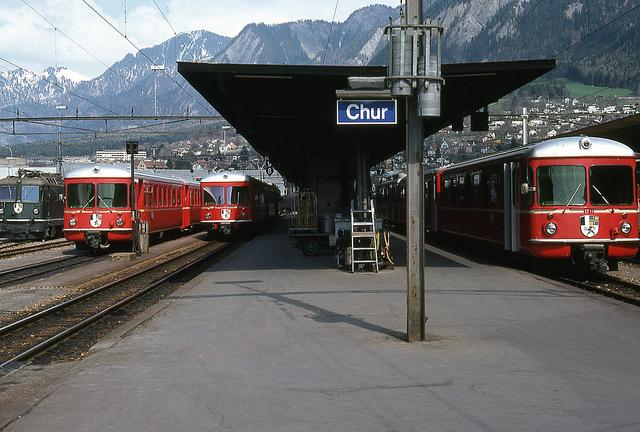What mountains are these?

Choices:
A) appalachian
B) rocky mountains
C) pyrenees
D) alps alps 